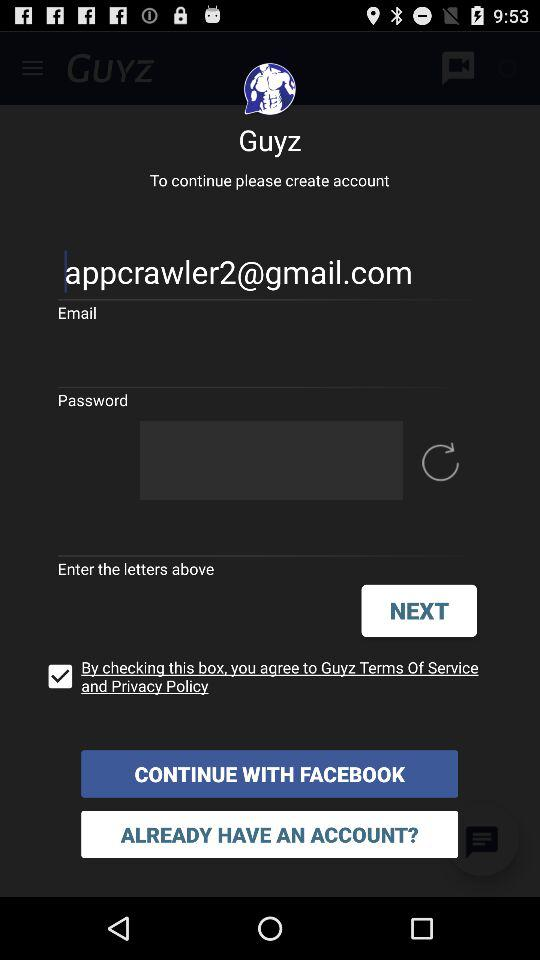What is the email address? The email address is appcrawler2@gmail.com. 